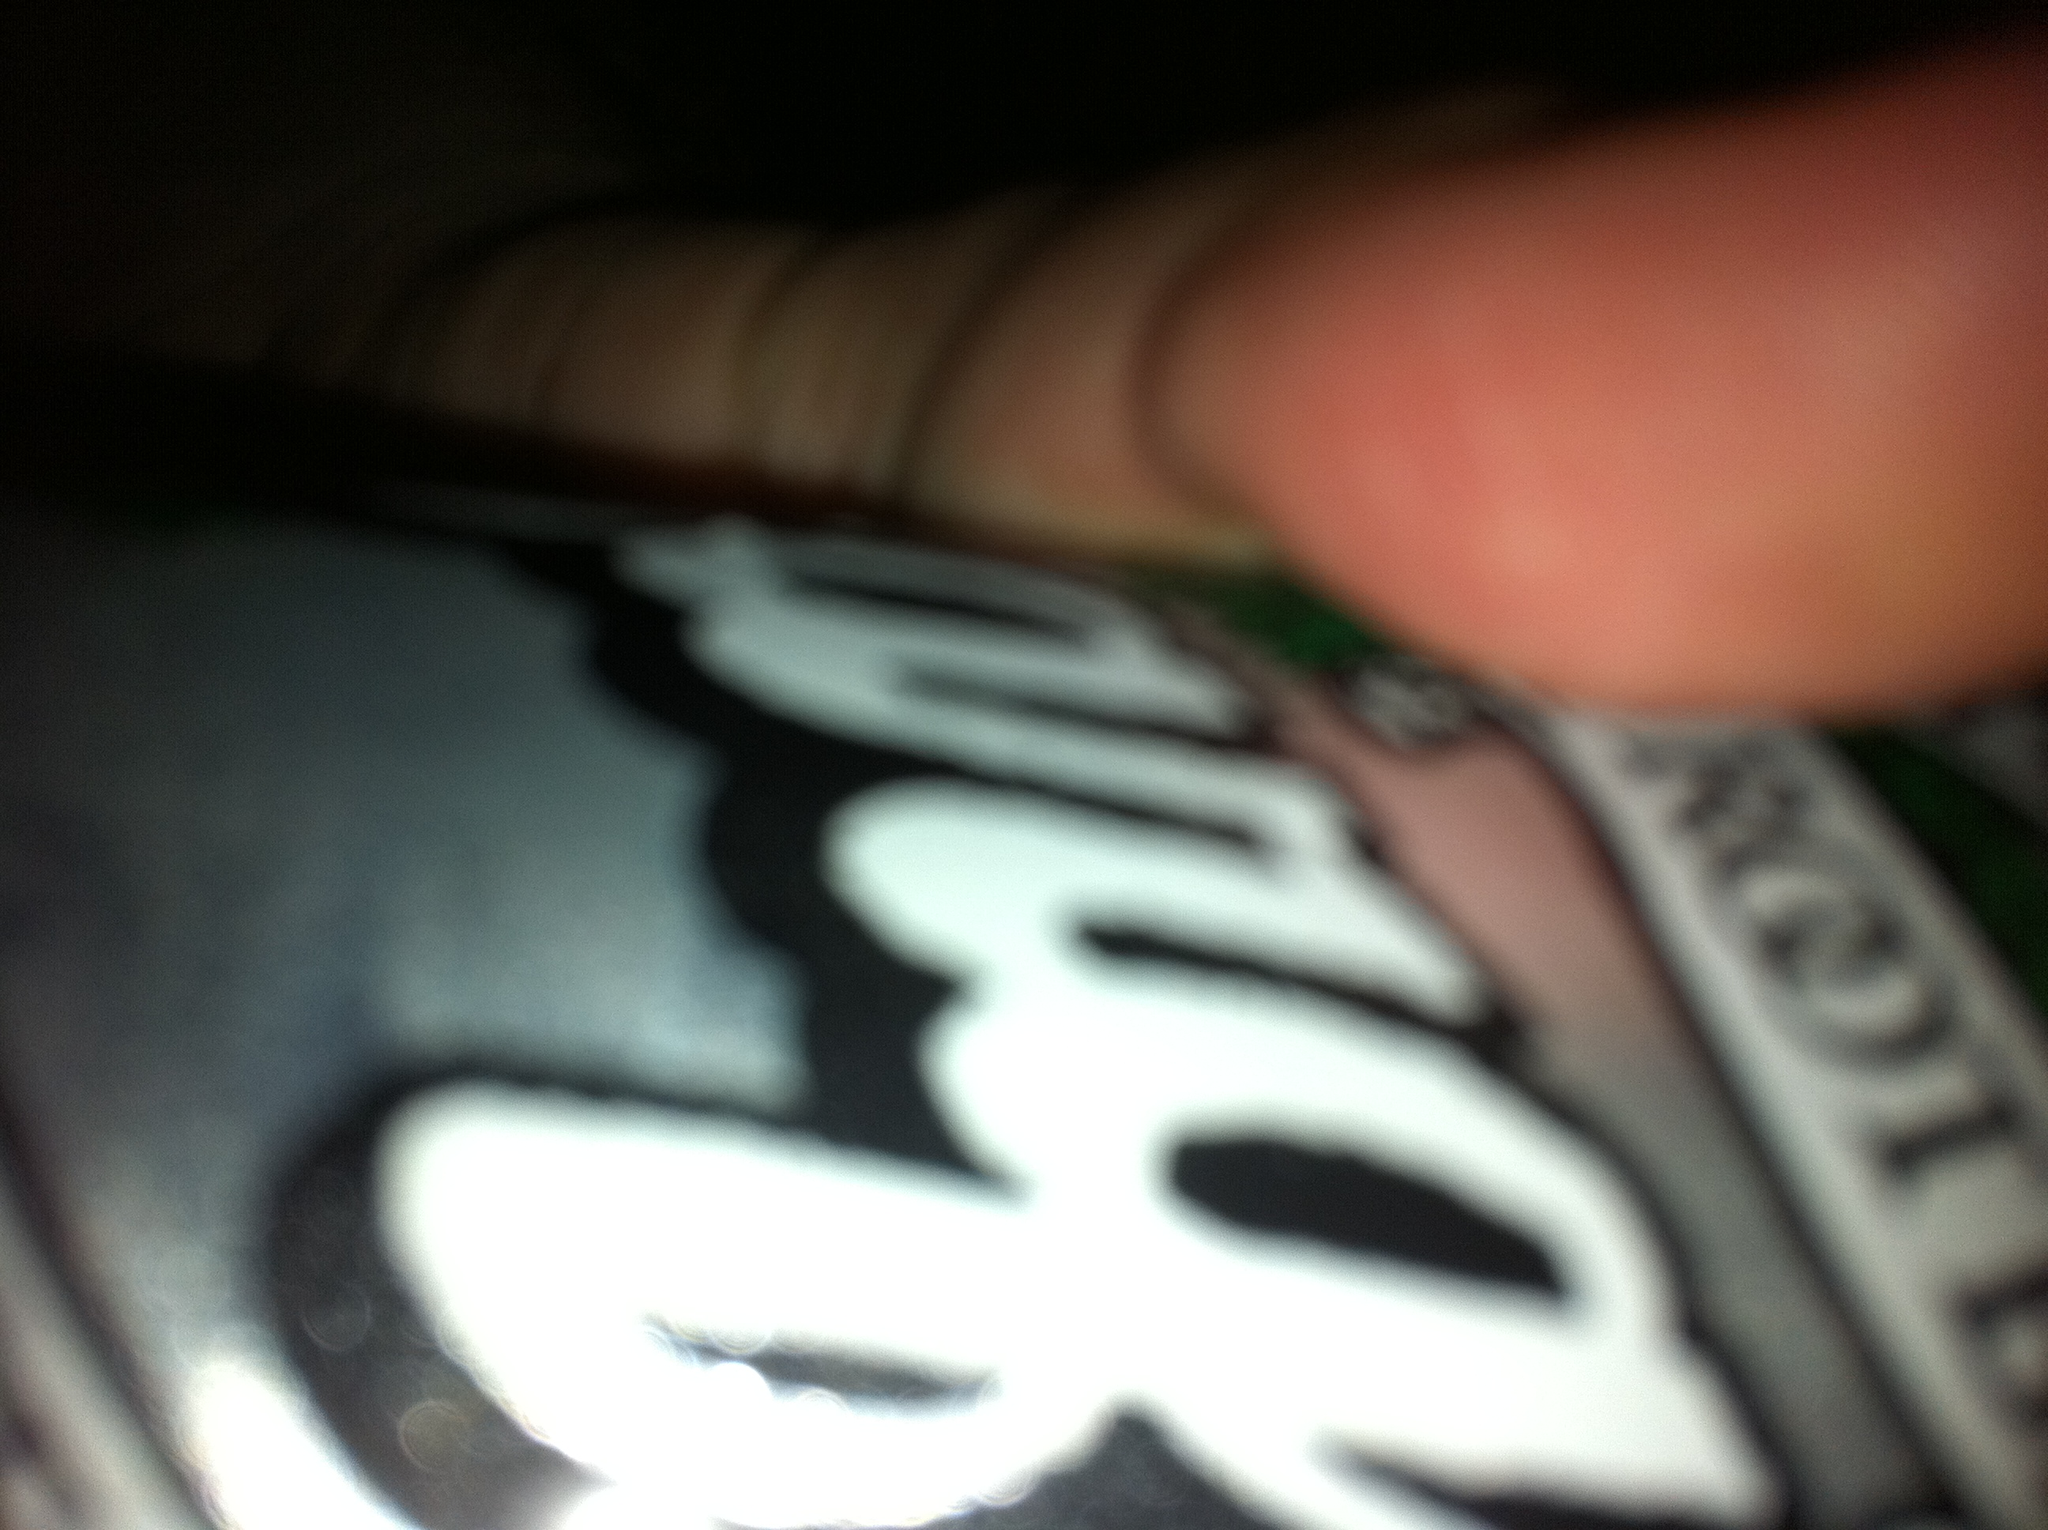Describe the flavor profile of this root beer. A&W Root Beer is known for its smooth and creamy texture. It has a rich vanilla flavor with hints of wintergreen and licorice, creating a distinctive and refreshing taste. 